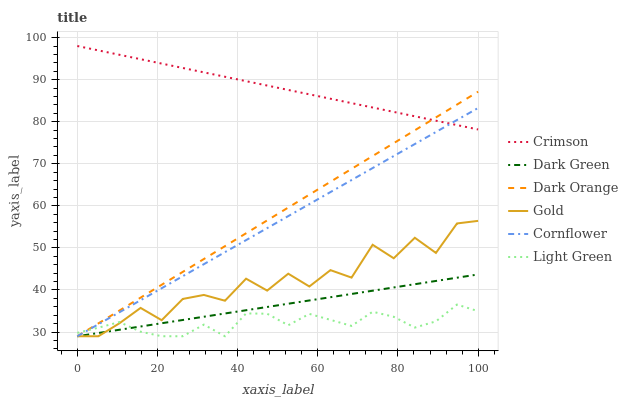Does Gold have the minimum area under the curve?
Answer yes or no. No. Does Gold have the maximum area under the curve?
Answer yes or no. No. Is Cornflower the smoothest?
Answer yes or no. No. Is Cornflower the roughest?
Answer yes or no. No. Does Crimson have the lowest value?
Answer yes or no. No. Does Gold have the highest value?
Answer yes or no. No. Is Dark Green less than Crimson?
Answer yes or no. Yes. Is Crimson greater than Gold?
Answer yes or no. Yes. Does Dark Green intersect Crimson?
Answer yes or no. No. 